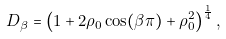<formula> <loc_0><loc_0><loc_500><loc_500>D _ { \beta } = \left ( 1 + 2 \rho _ { 0 } \cos ( \beta \pi ) + \rho _ { 0 } ^ { 2 } \right ) ^ { \frac { 1 } { 4 } } ,</formula> 